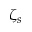Convert formula to latex. <formula><loc_0><loc_0><loc_500><loc_500>\zeta _ { s }</formula> 